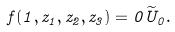<formula> <loc_0><loc_0><loc_500><loc_500>f ( 1 , z _ { 1 } , z _ { 2 } , z _ { 3 } ) = 0 \widetilde { U } _ { 0 } .</formula> 